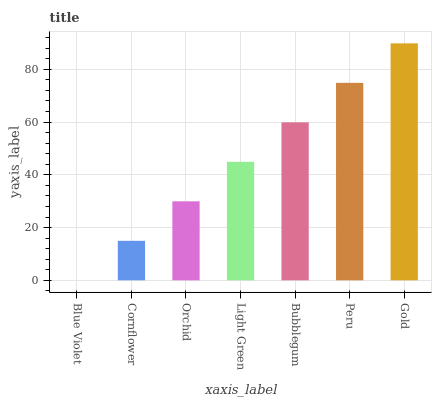Is Blue Violet the minimum?
Answer yes or no. Yes. Is Gold the maximum?
Answer yes or no. Yes. Is Cornflower the minimum?
Answer yes or no. No. Is Cornflower the maximum?
Answer yes or no. No. Is Cornflower greater than Blue Violet?
Answer yes or no. Yes. Is Blue Violet less than Cornflower?
Answer yes or no. Yes. Is Blue Violet greater than Cornflower?
Answer yes or no. No. Is Cornflower less than Blue Violet?
Answer yes or no. No. Is Light Green the high median?
Answer yes or no. Yes. Is Light Green the low median?
Answer yes or no. Yes. Is Orchid the high median?
Answer yes or no. No. Is Gold the low median?
Answer yes or no. No. 